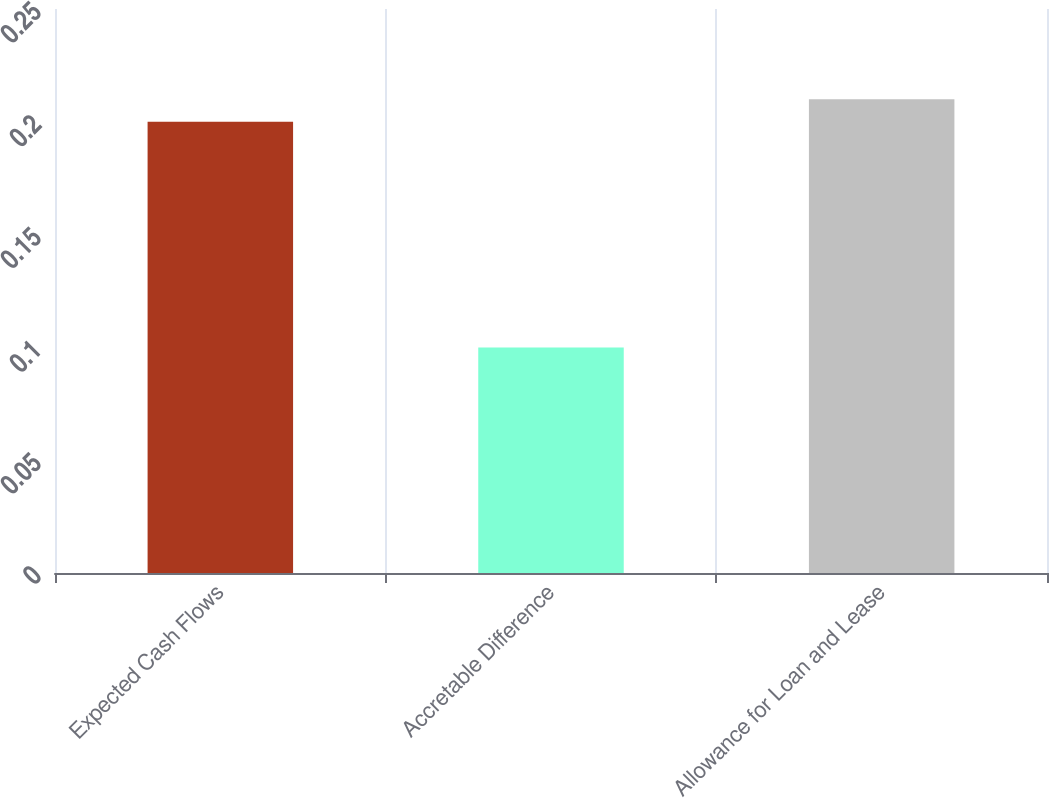Convert chart. <chart><loc_0><loc_0><loc_500><loc_500><bar_chart><fcel>Expected Cash Flows<fcel>Accretable Difference<fcel>Allowance for Loan and Lease<nl><fcel>0.2<fcel>0.1<fcel>0.21<nl></chart> 